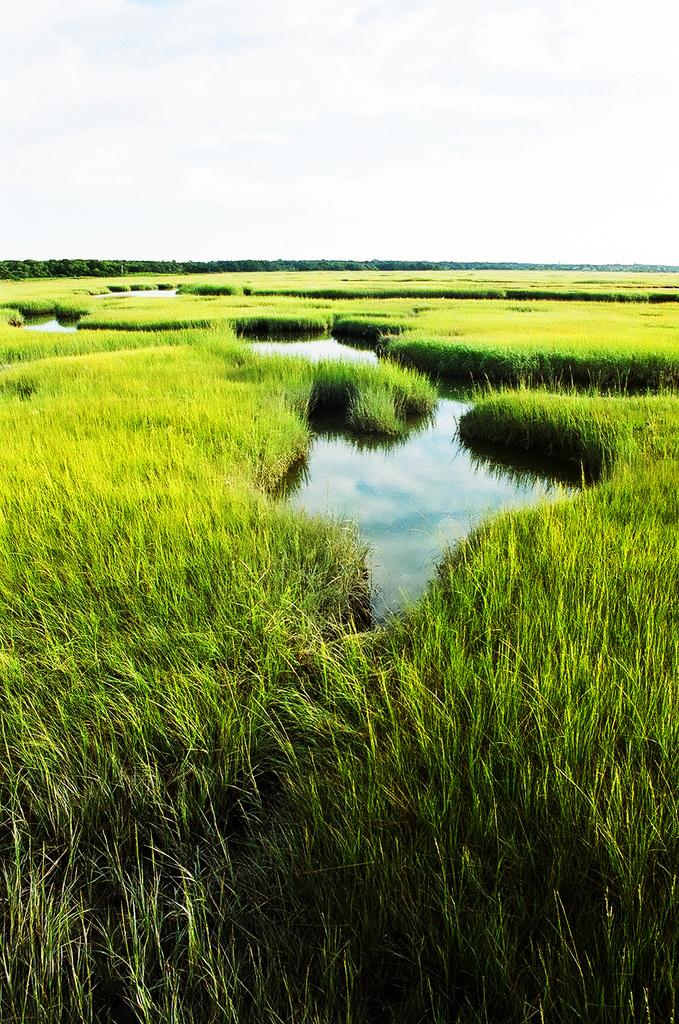What type of vegetation is present in the image? There is grass in the image. What is the color of the grass? The grass is green. What else can be seen in the image besides the grass? There is water visible in the image. What is the color of the sky in the image? The sky is white in color. What type of structure can be seen in the image? There is no structure present in the image; it primarily features grass, water, and a white sky. 